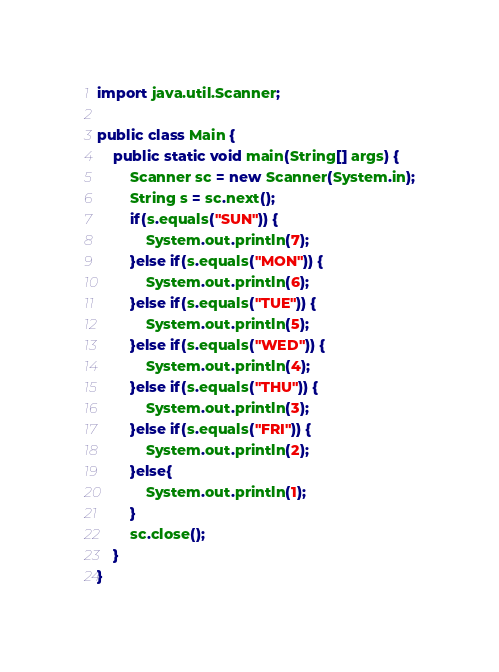<code> <loc_0><loc_0><loc_500><loc_500><_Java_>import java.util.Scanner;

public class Main {
	public static void main(String[] args) {
		Scanner sc = new Scanner(System.in);
		String s = sc.next();
		if(s.equals("SUN")) {
			System.out.println(7);
		}else if(s.equals("MON")) {
			System.out.println(6);
		}else if(s.equals("TUE")) {
			System.out.println(5);
		}else if(s.equals("WED")) {
			System.out.println(4);
		}else if(s.equals("THU")) {
			System.out.println(3);
		}else if(s.equals("FRI")) {
			System.out.println(2);
		}else{
			System.out.println(1);
		}
		sc.close();
	}
}
</code> 